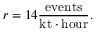Convert formula to latex. <formula><loc_0><loc_0><loc_500><loc_500>r = 1 4 { \frac { e v e n t s } { k t \cdot h o u r } } .</formula> 